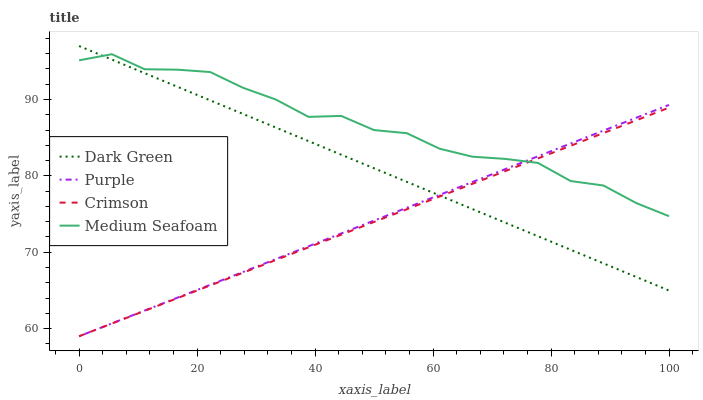Does Crimson have the minimum area under the curve?
Answer yes or no. Yes. Does Medium Seafoam have the maximum area under the curve?
Answer yes or no. Yes. Does Medium Seafoam have the minimum area under the curve?
Answer yes or no. No. Does Crimson have the maximum area under the curve?
Answer yes or no. No. Is Purple the smoothest?
Answer yes or no. Yes. Is Medium Seafoam the roughest?
Answer yes or no. Yes. Is Crimson the smoothest?
Answer yes or no. No. Is Crimson the roughest?
Answer yes or no. No. Does Medium Seafoam have the lowest value?
Answer yes or no. No. Does Dark Green have the highest value?
Answer yes or no. Yes. Does Medium Seafoam have the highest value?
Answer yes or no. No. Does Dark Green intersect Crimson?
Answer yes or no. Yes. Is Dark Green less than Crimson?
Answer yes or no. No. Is Dark Green greater than Crimson?
Answer yes or no. No. 